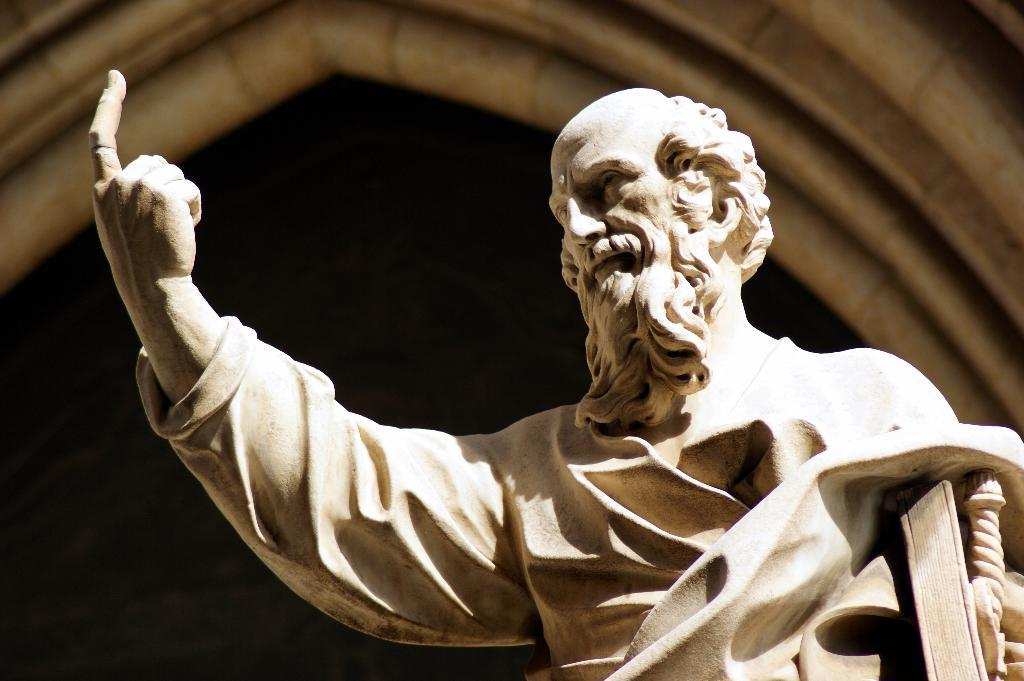What is the main subject of the image? There is a statue of a person in the image. Can you describe the statue? The statue is of a person. What can be seen in the background of the image? There is a building visible in the background of the image. What might the statue represent or symbolize? The statue's meaning or symbolism is not explicitly stated in the image, but it could represent a historical figure, an artist's vision, or a cultural symbol. What type of badge is the statue holding in the image? There is no badge visible in the image. 